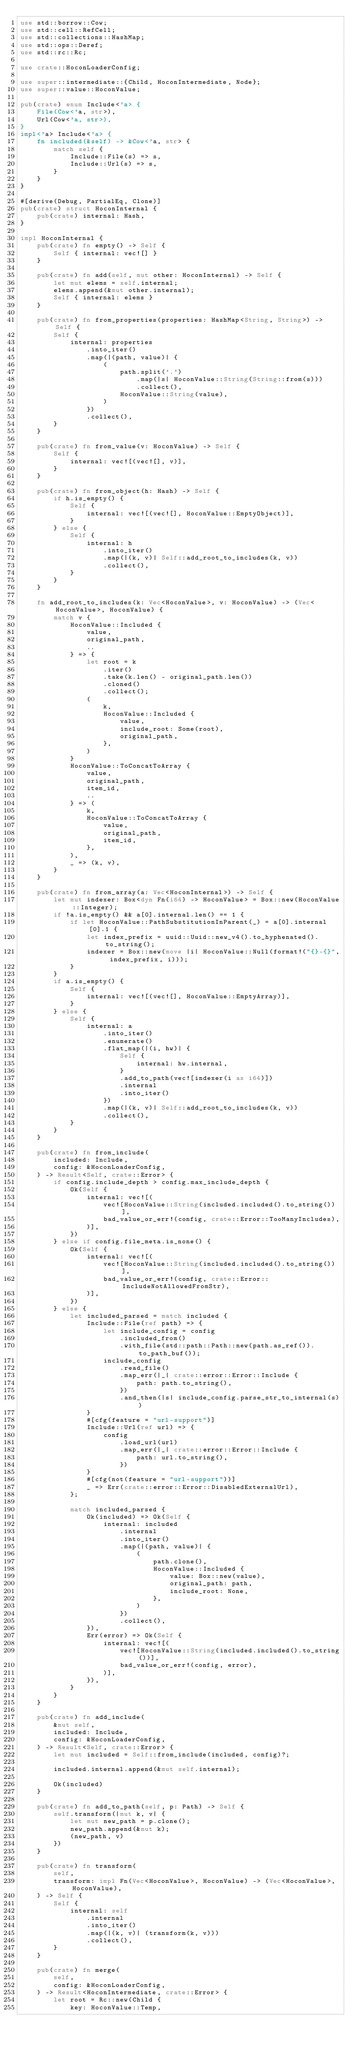Convert code to text. <code><loc_0><loc_0><loc_500><loc_500><_Rust_>use std::borrow::Cow;
use std::cell::RefCell;
use std::collections::HashMap;
use std::ops::Deref;
use std::rc::Rc;

use crate::HoconLoaderConfig;

use super::intermediate::{Child, HoconIntermediate, Node};
use super::value::HoconValue;

pub(crate) enum Include<'a> {
    File(Cow<'a, str>),
    Url(Cow<'a, str>),
}
impl<'a> Include<'a> {
    fn included(&self) -> &Cow<'a, str> {
        match self {
            Include::File(s) => s,
            Include::Url(s) => s,
        }
    }
}

#[derive(Debug, PartialEq, Clone)]
pub(crate) struct HoconInternal {
    pub(crate) internal: Hash,
}

impl HoconInternal {
    pub(crate) fn empty() -> Self {
        Self { internal: vec![] }
    }

    pub(crate) fn add(self, mut other: HoconInternal) -> Self {
        let mut elems = self.internal;
        elems.append(&mut other.internal);
        Self { internal: elems }
    }

    pub(crate) fn from_properties(properties: HashMap<String, String>) -> Self {
        Self {
            internal: properties
                .into_iter()
                .map(|(path, value)| {
                    (
                        path.split('.')
                            .map(|s| HoconValue::String(String::from(s)))
                            .collect(),
                        HoconValue::String(value),
                    )
                })
                .collect(),
        }
    }

    pub(crate) fn from_value(v: HoconValue) -> Self {
        Self {
            internal: vec![(vec![], v)],
        }
    }

    pub(crate) fn from_object(h: Hash) -> Self {
        if h.is_empty() {
            Self {
                internal: vec![(vec![], HoconValue::EmptyObject)],
            }
        } else {
            Self {
                internal: h
                    .into_iter()
                    .map(|(k, v)| Self::add_root_to_includes(k, v))
                    .collect(),
            }
        }
    }

    fn add_root_to_includes(k: Vec<HoconValue>, v: HoconValue) -> (Vec<HoconValue>, HoconValue) {
        match v {
            HoconValue::Included {
                value,
                original_path,
                ..
            } => {
                let root = k
                    .iter()
                    .take(k.len() - original_path.len())
                    .cloned()
                    .collect();
                (
                    k,
                    HoconValue::Included {
                        value,
                        include_root: Some(root),
                        original_path,
                    },
                )
            }
            HoconValue::ToConcatToArray {
                value,
                original_path,
                item_id,
                ..
            } => (
                k,
                HoconValue::ToConcatToArray {
                    value,
                    original_path,
                    item_id,
                },
            ),
            _ => (k, v),
        }
    }

    pub(crate) fn from_array(a: Vec<HoconInternal>) -> Self {
        let mut indexer: Box<dyn Fn(i64) -> HoconValue> = Box::new(HoconValue::Integer);
        if !a.is_empty() && a[0].internal.len() == 1 {
            if let HoconValue::PathSubstitutionInParent(_) = a[0].internal[0].1 {
                let index_prefix = uuid::Uuid::new_v4().to_hyphenated().to_string();
                indexer = Box::new(move |i| HoconValue::Null(format!("{}-{}", index_prefix, i)));
            }
        }
        if a.is_empty() {
            Self {
                internal: vec![(vec![], HoconValue::EmptyArray)],
            }
        } else {
            Self {
                internal: a
                    .into_iter()
                    .enumerate()
                    .flat_map(|(i, hw)| {
                        Self {
                            internal: hw.internal,
                        }
                        .add_to_path(vec![indexer(i as i64)])
                        .internal
                        .into_iter()
                    })
                    .map(|(k, v)| Self::add_root_to_includes(k, v))
                    .collect(),
            }
        }
    }

    pub(crate) fn from_include(
        included: Include,
        config: &HoconLoaderConfig,
    ) -> Result<Self, crate::Error> {
        if config.include_depth > config.max_include_depth {
            Ok(Self {
                internal: vec![(
                    vec![HoconValue::String(included.included().to_string())],
                    bad_value_or_err!(config, crate::Error::TooManyIncludes),
                )],
            })
        } else if config.file_meta.is_none() {
            Ok(Self {
                internal: vec![(
                    vec![HoconValue::String(included.included().to_string())],
                    bad_value_or_err!(config, crate::Error::IncludeNotAllowedFromStr),
                )],
            })
        } else {
            let included_parsed = match included {
                Include::File(ref path) => {
                    let include_config = config
                        .included_from()
                        .with_file(std::path::Path::new(path.as_ref()).to_path_buf());
                    include_config
                        .read_file()
                        .map_err(|_| crate::error::Error::Include {
                            path: path.to_string(),
                        })
                        .and_then(|s| include_config.parse_str_to_internal(s))
                }
                #[cfg(feature = "url-support")]
                Include::Url(ref url) => {
                    config
                        .load_url(url)
                        .map_err(|_| crate::error::Error::Include {
                            path: url.to_string(),
                        })
                }
                #[cfg(not(feature = "url-support"))]
                _ => Err(crate::error::Error::DisabledExternalUrl),
            };

            match included_parsed {
                Ok(included) => Ok(Self {
                    internal: included
                        .internal
                        .into_iter()
                        .map(|(path, value)| {
                            (
                                path.clone(),
                                HoconValue::Included {
                                    value: Box::new(value),
                                    original_path: path,
                                    include_root: None,
                                },
                            )
                        })
                        .collect(),
                }),
                Err(error) => Ok(Self {
                    internal: vec![(
                        vec![HoconValue::String(included.included().to_string())],
                        bad_value_or_err!(config, error),
                    )],
                }),
            }
        }
    }

    pub(crate) fn add_include(
        &mut self,
        included: Include,
        config: &HoconLoaderConfig,
    ) -> Result<Self, crate::Error> {
        let mut included = Self::from_include(included, config)?;

        included.internal.append(&mut self.internal);

        Ok(included)
    }

    pub(crate) fn add_to_path(self, p: Path) -> Self {
        self.transform(|mut k, v| {
            let mut new_path = p.clone();
            new_path.append(&mut k);
            (new_path, v)
        })
    }

    pub(crate) fn transform(
        self,
        transform: impl Fn(Vec<HoconValue>, HoconValue) -> (Vec<HoconValue>, HoconValue),
    ) -> Self {
        Self {
            internal: self
                .internal
                .into_iter()
                .map(|(k, v)| (transform(k, v)))
                .collect(),
        }
    }

    pub(crate) fn merge(
        self,
        config: &HoconLoaderConfig,
    ) -> Result<HoconIntermediate, crate::Error> {
        let root = Rc::new(Child {
            key: HoconValue::Temp,</code> 